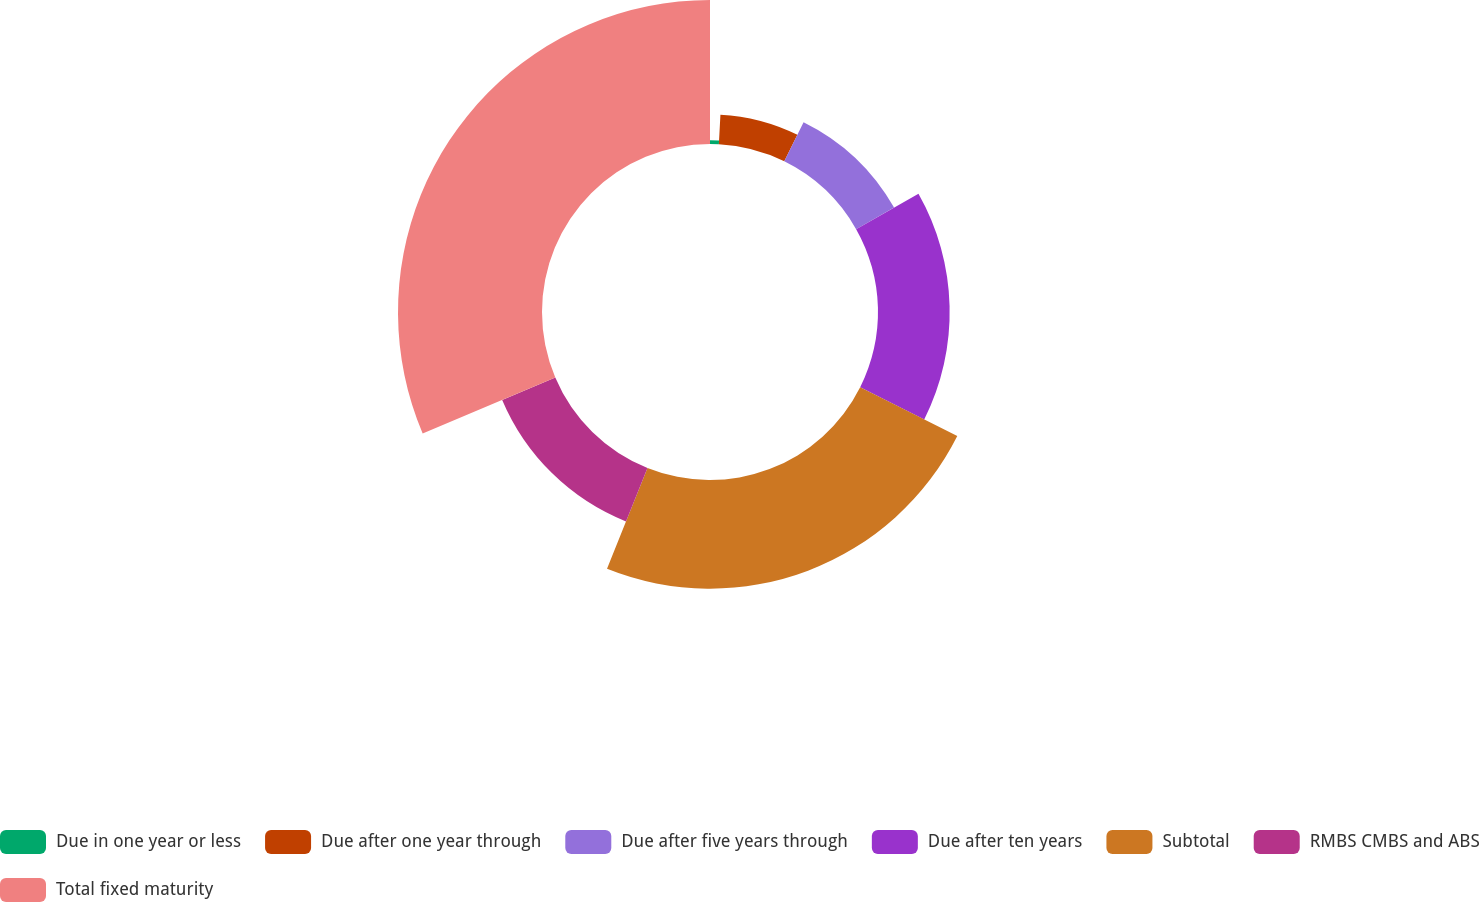Convert chart. <chart><loc_0><loc_0><loc_500><loc_500><pie_chart><fcel>Due in one year or less<fcel>Due after one year through<fcel>Due after five years through<fcel>Due after ten years<fcel>Subtotal<fcel>RMBS CMBS and ABS<fcel>Total fixed maturity<nl><fcel>0.84%<fcel>6.45%<fcel>9.5%<fcel>15.61%<fcel>23.67%<fcel>12.56%<fcel>31.37%<nl></chart> 